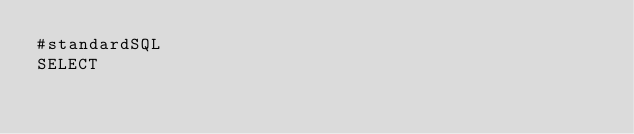<code> <loc_0><loc_0><loc_500><loc_500><_SQL_>#standardSQL
SELECT</code> 